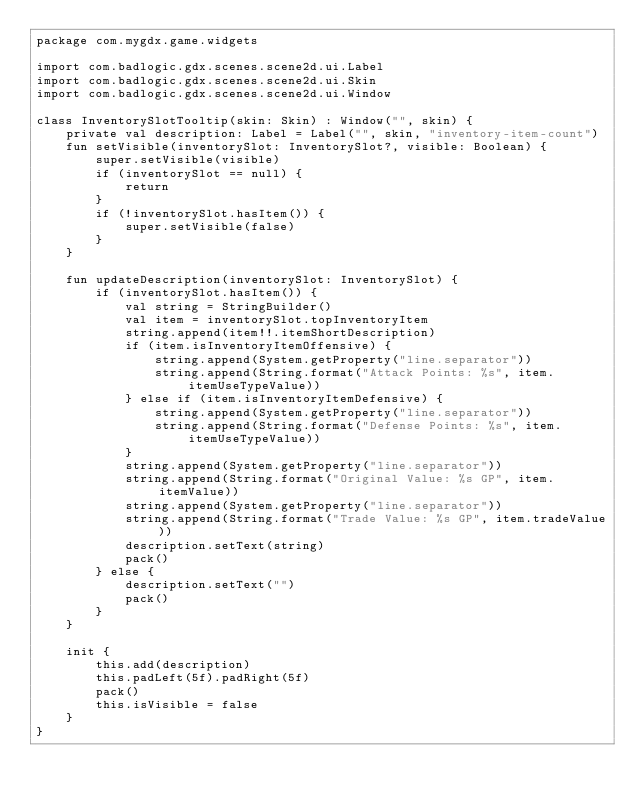Convert code to text. <code><loc_0><loc_0><loc_500><loc_500><_Kotlin_>package com.mygdx.game.widgets

import com.badlogic.gdx.scenes.scene2d.ui.Label
import com.badlogic.gdx.scenes.scene2d.ui.Skin
import com.badlogic.gdx.scenes.scene2d.ui.Window

class InventorySlotTooltip(skin: Skin) : Window("", skin) {
    private val description: Label = Label("", skin, "inventory-item-count")
    fun setVisible(inventorySlot: InventorySlot?, visible: Boolean) {
        super.setVisible(visible)
        if (inventorySlot == null) {
            return
        }
        if (!inventorySlot.hasItem()) {
            super.setVisible(false)
        }
    }

    fun updateDescription(inventorySlot: InventorySlot) {
        if (inventorySlot.hasItem()) {
            val string = StringBuilder()
            val item = inventorySlot.topInventoryItem
            string.append(item!!.itemShortDescription)
            if (item.isInventoryItemOffensive) {
                string.append(System.getProperty("line.separator"))
                string.append(String.format("Attack Points: %s", item.itemUseTypeValue))
            } else if (item.isInventoryItemDefensive) {
                string.append(System.getProperty("line.separator"))
                string.append(String.format("Defense Points: %s", item.itemUseTypeValue))
            }
            string.append(System.getProperty("line.separator"))
            string.append(String.format("Original Value: %s GP", item.itemValue))
            string.append(System.getProperty("line.separator"))
            string.append(String.format("Trade Value: %s GP", item.tradeValue))
            description.setText(string)
            pack()
        } else {
            description.setText("")
            pack()
        }
    }

    init {
        this.add(description)
        this.padLeft(5f).padRight(5f)
        pack()
        this.isVisible = false
    }
}</code> 